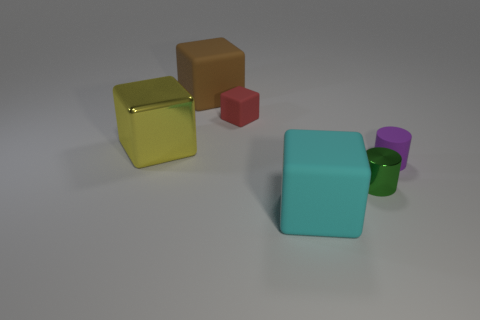Subtract 1 blocks. How many blocks are left? 3 Add 1 tiny purple objects. How many objects exist? 7 Subtract all purple blocks. Subtract all purple cylinders. How many blocks are left? 4 Subtract all blocks. How many objects are left? 2 Subtract 0 green blocks. How many objects are left? 6 Subtract all green metallic cylinders. Subtract all small green metal cylinders. How many objects are left? 4 Add 6 big yellow metal cubes. How many big yellow metal cubes are left? 7 Add 2 small things. How many small things exist? 5 